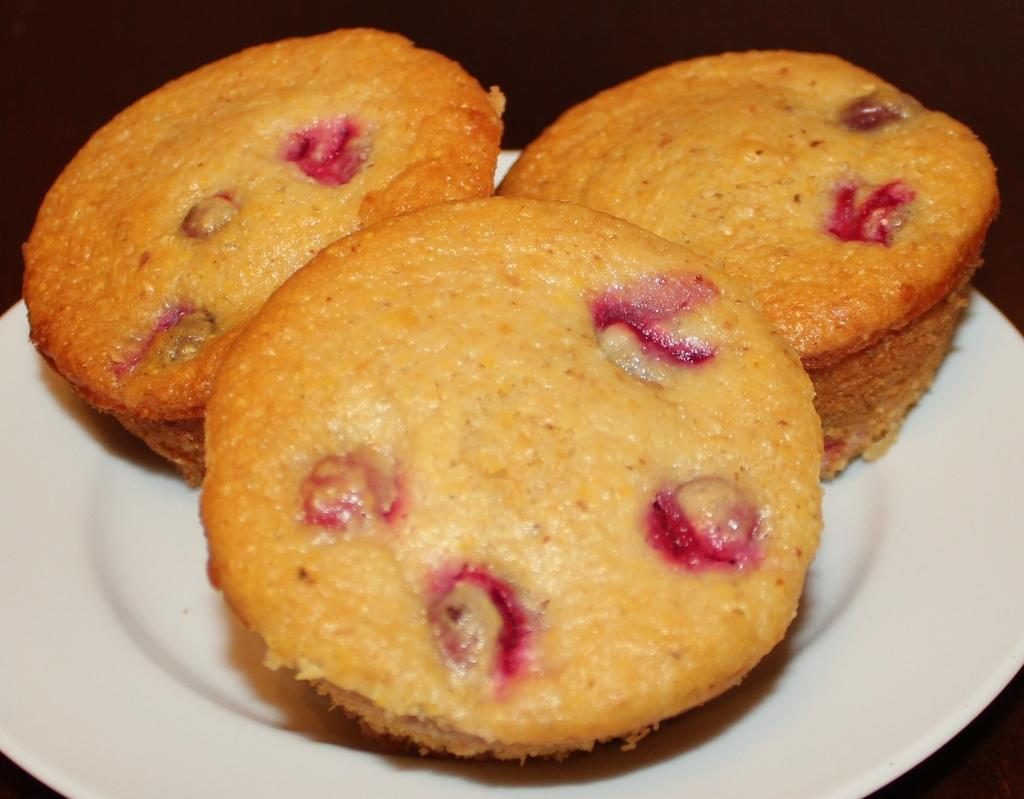What is present on the plate in the image? There are three muffins on the plate in the image. What can be observed in the background of the image? The background of the image is dark. How many books are on the plate with the muffins? There are no books present on the plate with the muffins; only three muffins are visible. What type of magic is being performed with the tooth in the image? There is no tooth or magic present in the image. 